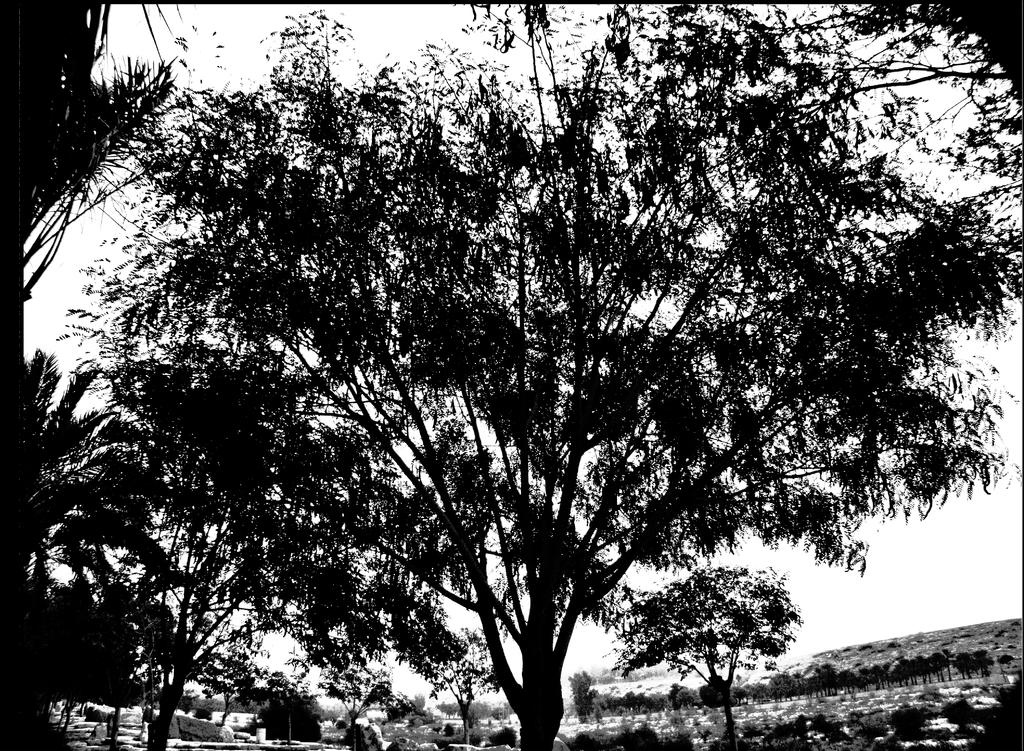What is the color scheme of the image? The image is black and white. What type of natural elements can be seen in the image? There are trees in the image. What part of the natural environment is visible in the background of the image? The sky is visible in the background of the image. What type of soap is being used to wash the trees in the image? There is no soap or washing activity present in the image; it features trees and a sky. What flavor of jam can be seen on the branches of the trees in the image? There is no jam present in the image; it features trees and a sky. 